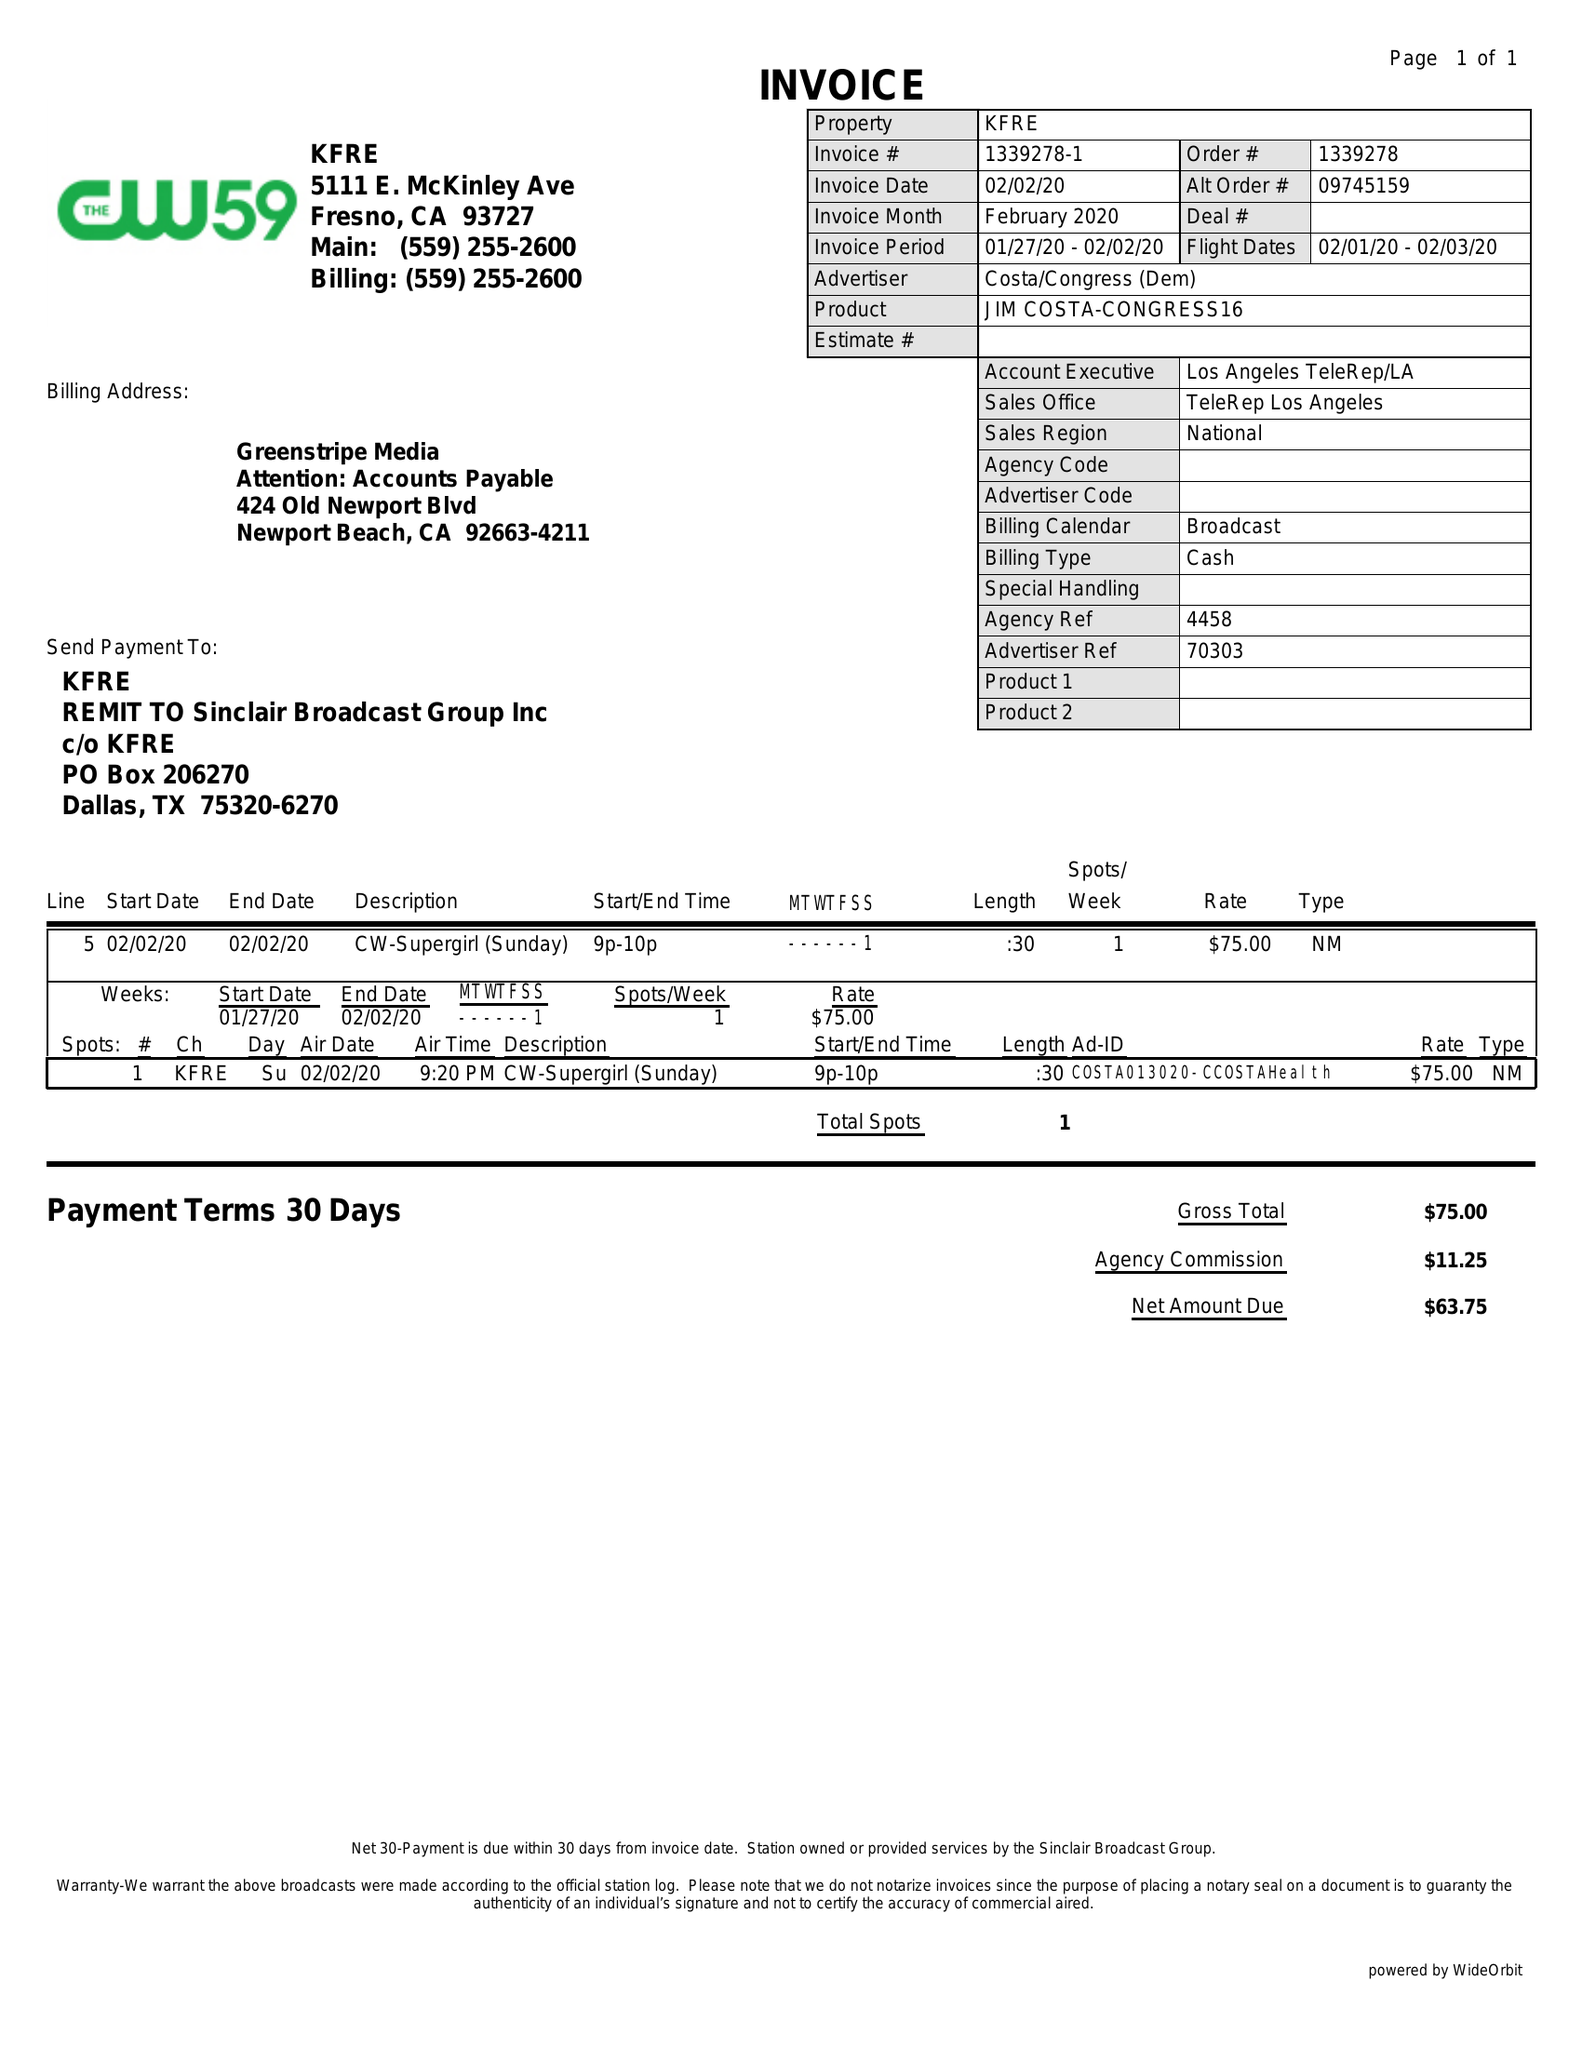What is the value for the flight_from?
Answer the question using a single word or phrase. 02/01/20 